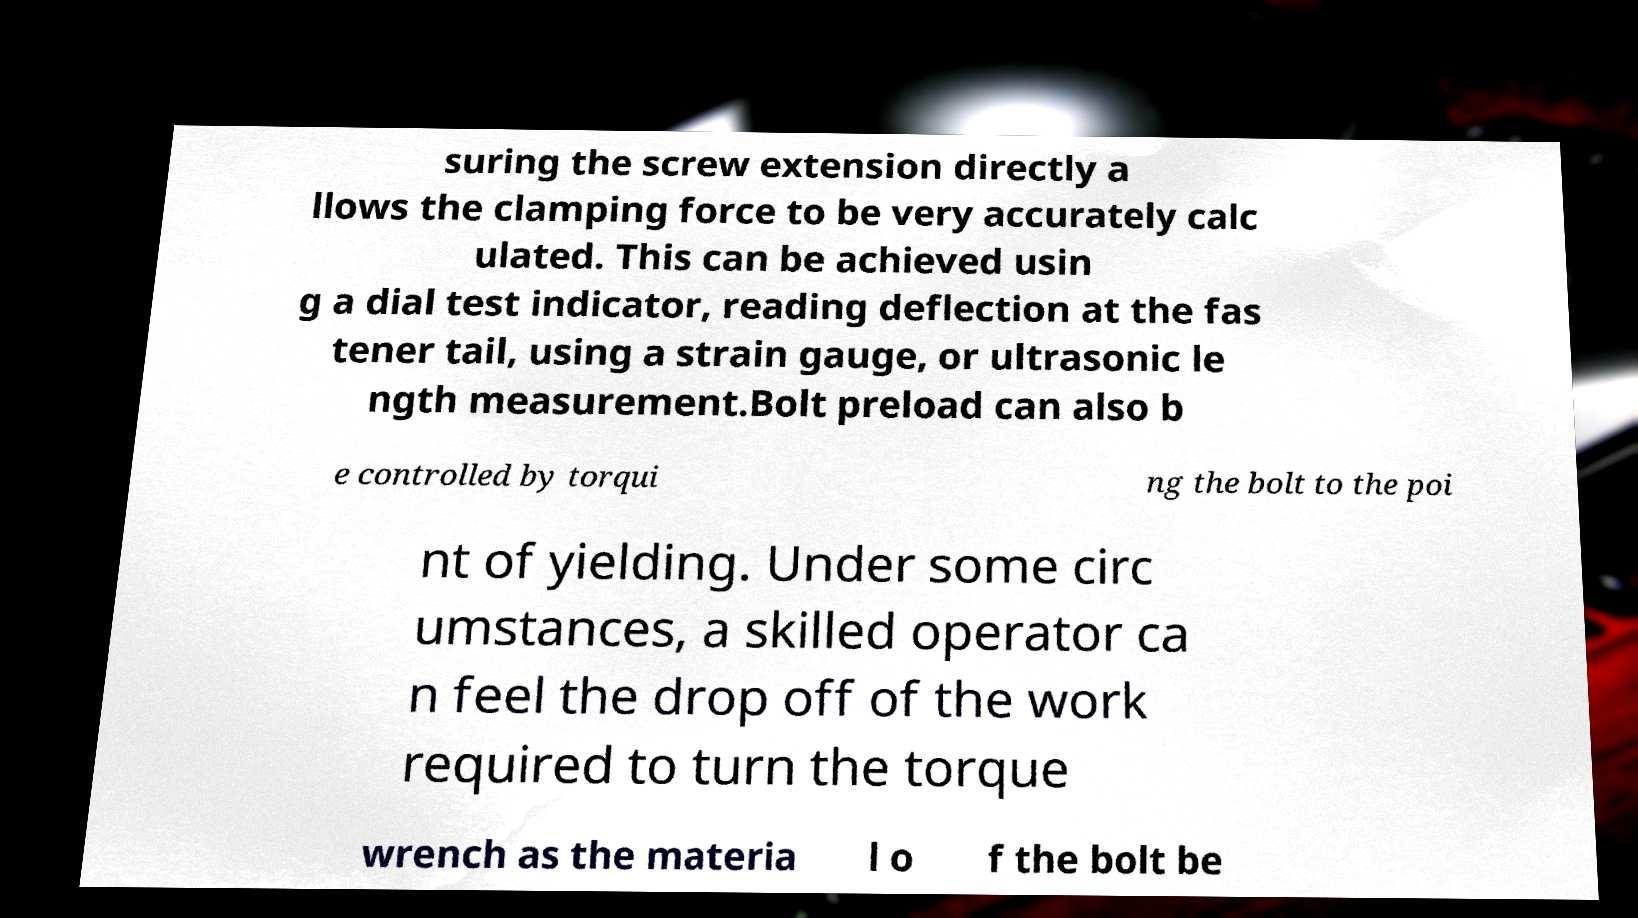Can you read and provide the text displayed in the image?This photo seems to have some interesting text. Can you extract and type it out for me? suring the screw extension directly a llows the clamping force to be very accurately calc ulated. This can be achieved usin g a dial test indicator, reading deflection at the fas tener tail, using a strain gauge, or ultrasonic le ngth measurement.Bolt preload can also b e controlled by torqui ng the bolt to the poi nt of yielding. Under some circ umstances, a skilled operator ca n feel the drop off of the work required to turn the torque wrench as the materia l o f the bolt be 